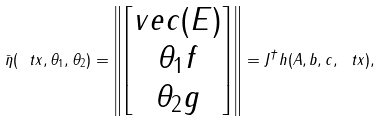<formula> <loc_0><loc_0><loc_500><loc_500>\bar { \eta } ( \ t x , \theta _ { 1 } , \theta _ { 2 } ) = \left \| \begin{bmatrix} v e c ( E ) \\ \theta _ { 1 } f \\ \theta _ { 2 } g \end{bmatrix} \right \| = \| J ^ { \dagger } h ( A , b , c , \ t x ) \| ,</formula> 